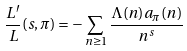Convert formula to latex. <formula><loc_0><loc_0><loc_500><loc_500>\frac { L ^ { \prime } } { L } ( s , \pi ) = - \sum _ { n \geq 1 } \frac { \Lambda ( n ) a _ { \pi } ( n ) } { n ^ { s } }</formula> 